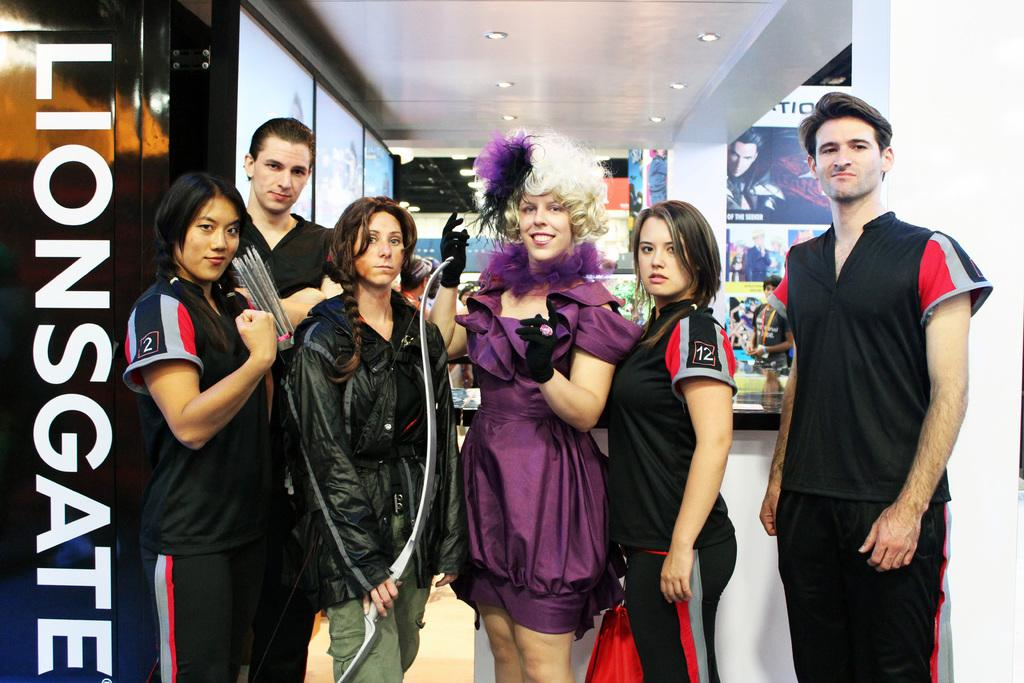<image>
Share a concise interpretation of the image provided. a few people posing near a Lionsgate wall 